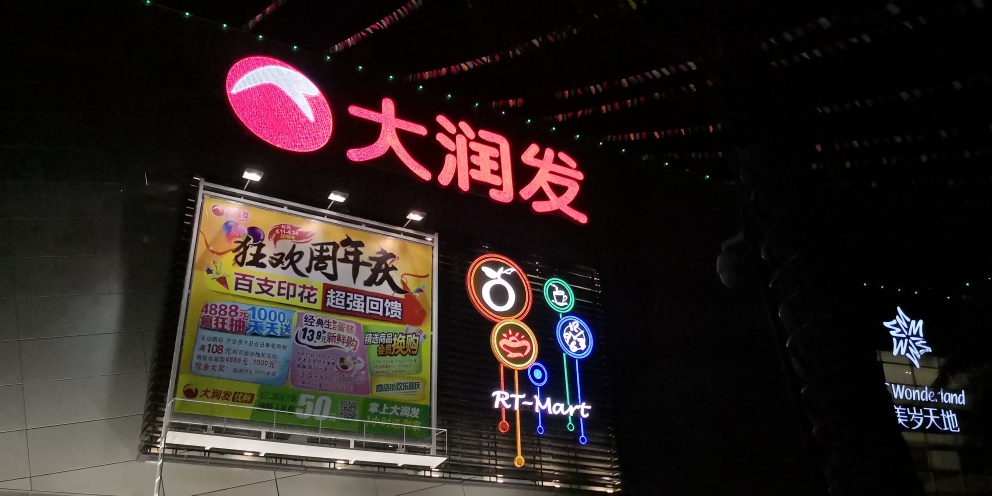What type of businesses are advertised in the neon signs? The neon signs advertise a variety of businesses. The largest sign indicates a supermarket named 'RT-Mart.' The colorful neon icons below suggest different categories of commodities available, such as food, home essentials, fashion, and probably electronics. Additionally, there's an advertisement for a place called 'Wonderland,' hinted to be a fun or entertainment venue with the star-like symbol. 